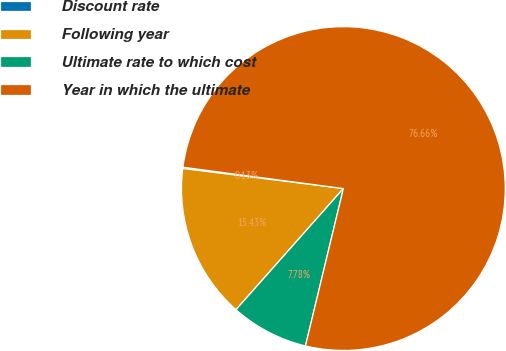Convert chart. <chart><loc_0><loc_0><loc_500><loc_500><pie_chart><fcel>Discount rate<fcel>Following year<fcel>Ultimate rate to which cost<fcel>Year in which the ultimate<nl><fcel>0.13%<fcel>15.43%<fcel>7.78%<fcel>76.66%<nl></chart> 